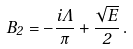<formula> <loc_0><loc_0><loc_500><loc_500>B _ { 2 } = - \frac { i \Lambda } \pi + \frac { \sqrt { E } } 2 \, .</formula> 